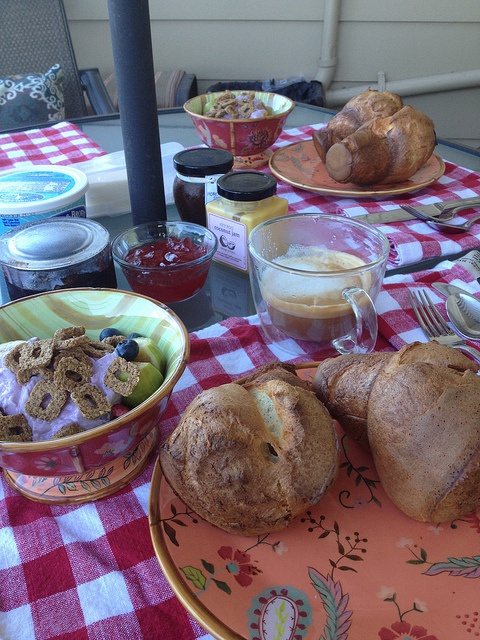Describe the objects in this image and their specific colors. I can see dining table in gray, brown, maroon, and darkgray tones, bowl in gray, maroon, and darkgray tones, cup in gray, darkgray, and lightblue tones, chair in gray, blue, and black tones, and bowl in gray, maroon, and black tones in this image. 